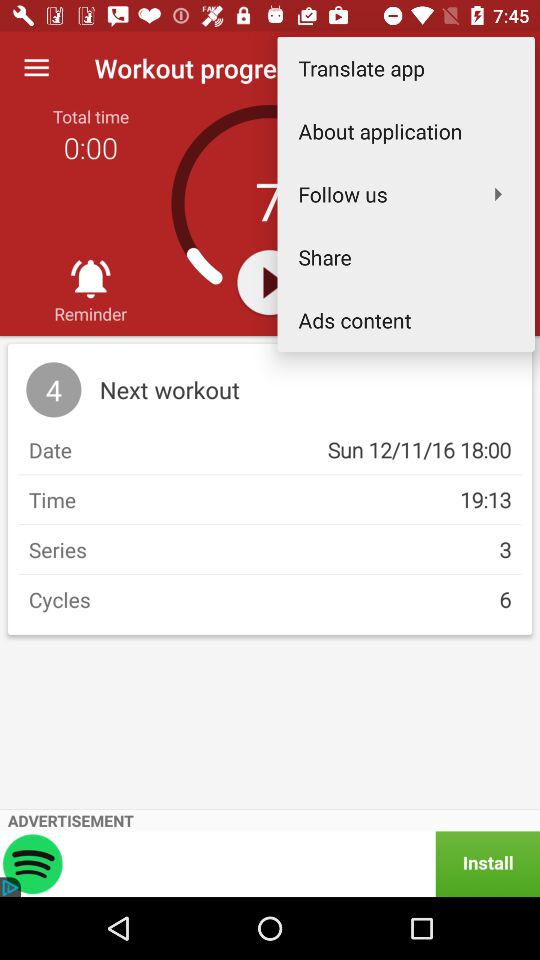What's the date? The date is Sunday, November 11, 2016. 